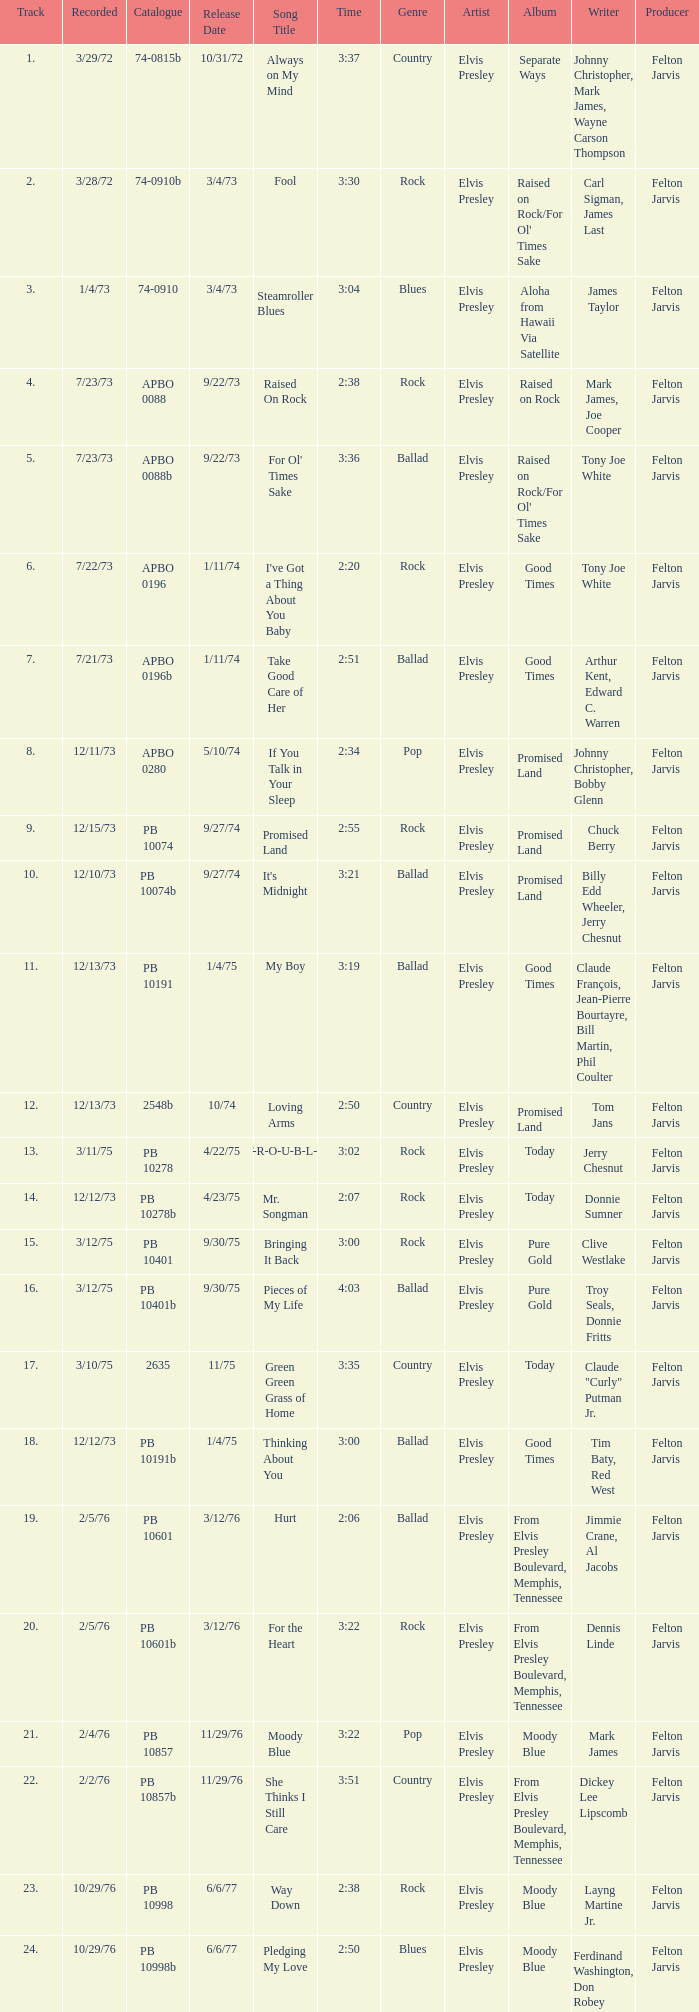Tell me the track that has the catalogue of apbo 0280 8.0. 